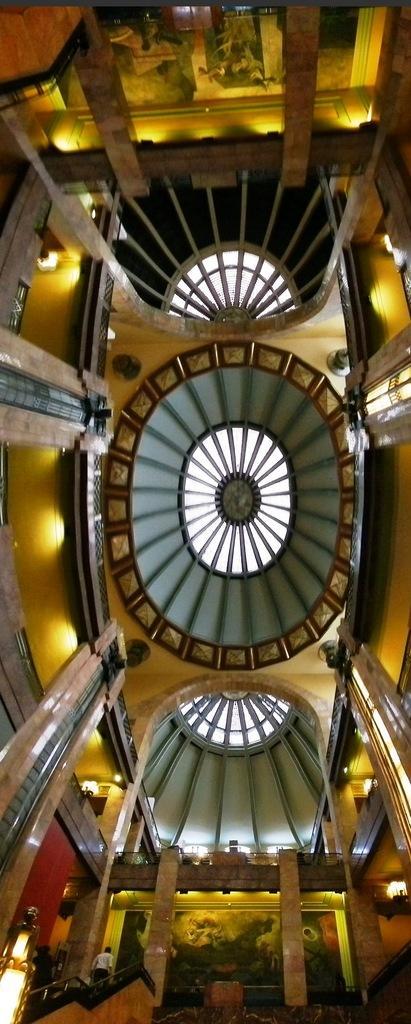Please provide a concise description of this image. This is an inside view of a building. In this image, we can see the ceiling with glass objects, few things and lights. At the bottom of the image, we can see person, lights, pillars, few objects and painting on the wall. On the right side and left side of the image, we can see pillars and railings. At the top of the image, we can see pillars, railings, lights and painting on the wall. 